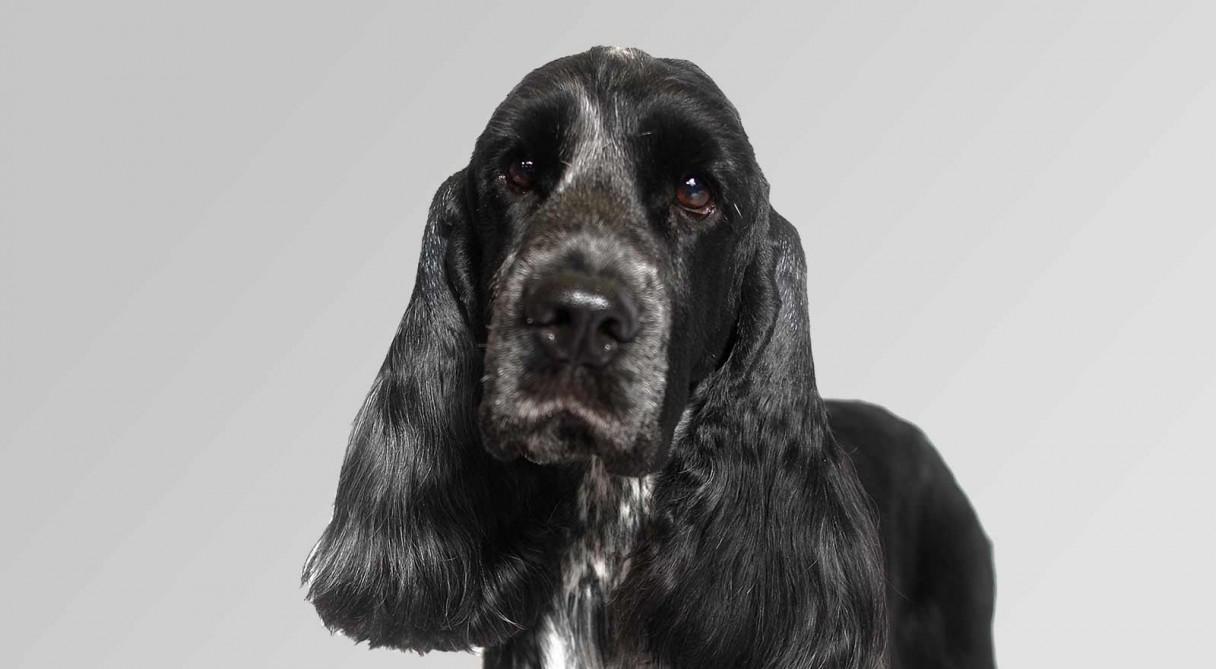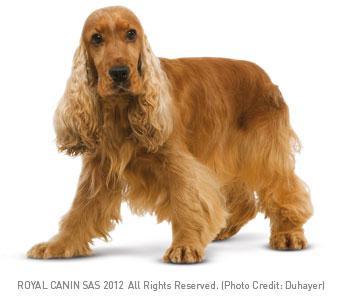The first image is the image on the left, the second image is the image on the right. For the images displayed, is the sentence "There are three dogs in one of the images." factually correct? Answer yes or no. No. 